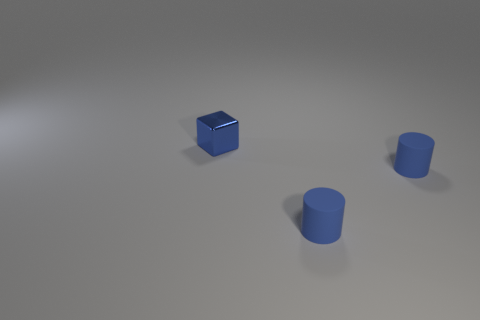What number of purple objects are tiny matte cylinders or metal objects?
Your answer should be very brief. 0. Are there fewer tiny cylinders than tiny metal objects?
Keep it short and to the point. No. Are there any big blue spheres?
Keep it short and to the point. No. Are there any small objects that have the same color as the cube?
Make the answer very short. Yes. What color is the block?
Your response must be concise. Blue. How many objects are the same material as the blue block?
Give a very brief answer. 0. What number of blue cylinders are left of the blue cube?
Your response must be concise. 0. Are there any other things that have the same shape as the small metal object?
Your response must be concise. No. Is there anything else that has the same size as the blue metal block?
Your response must be concise. Yes. How many objects are either small cubes or blue things that are on the right side of the metal object?
Provide a short and direct response. 3. 